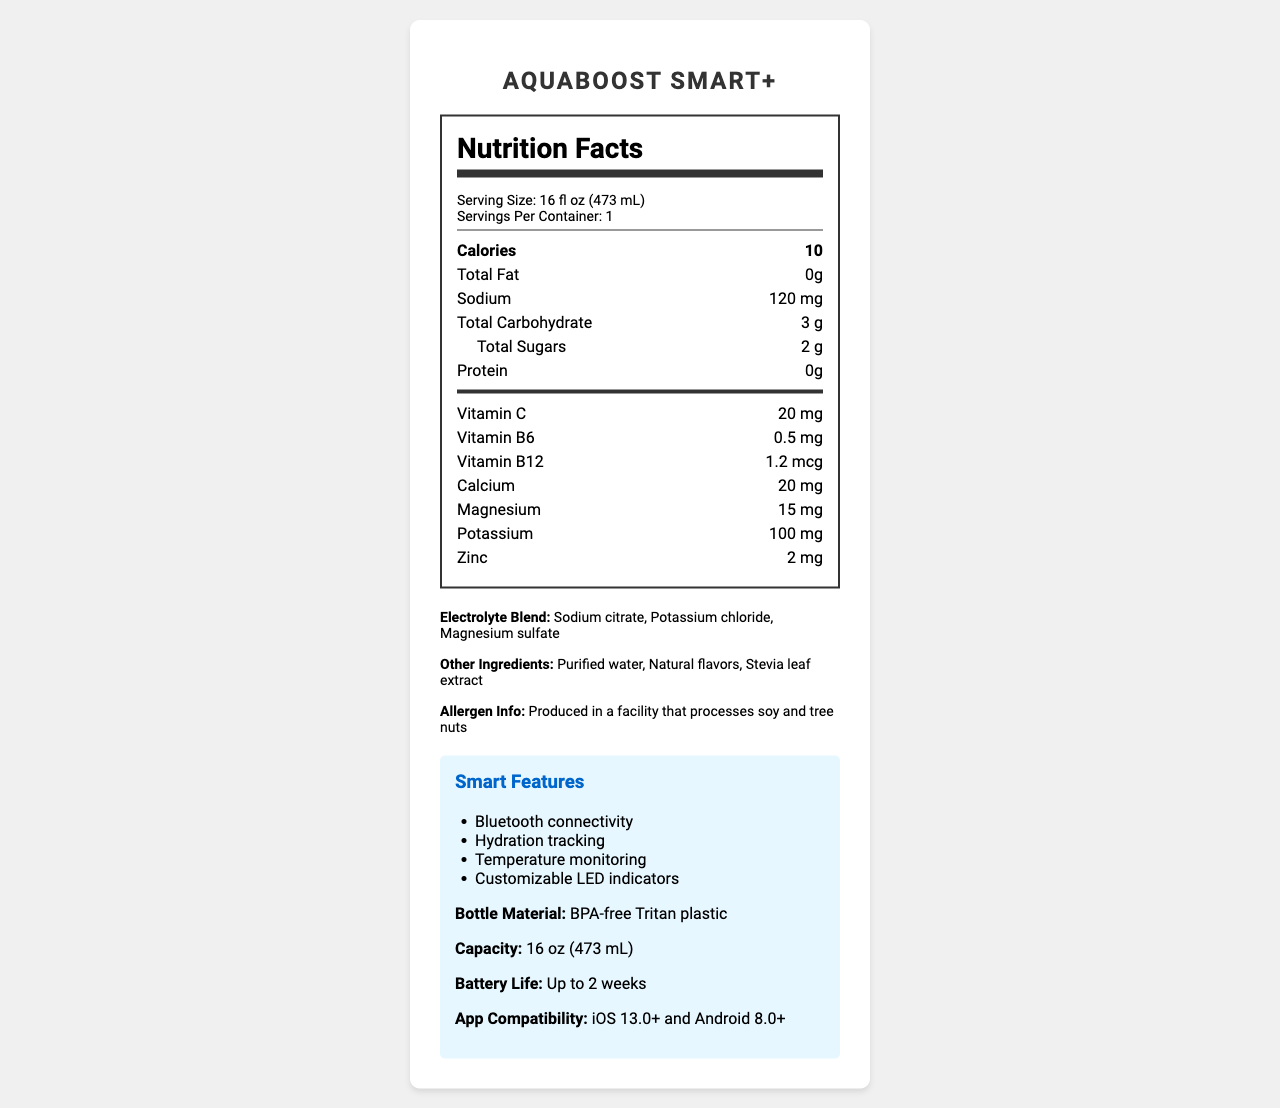what is the serving size? The serving size is specified near the top of the nutrition facts section.
Answer: 16 fl oz (473 mL) how many calories are in one serving? The number of calories per serving is listed prominently in the nutrition facts.
Answer: 10 how much sodium does the AquaBoost Smart+ contain per serving? The amount of sodium is listed in the nutrition facts under the nutrient section.
Answer: 120 mg what are the smart features of the AquaBoost Smart+? These features are listed in the smart features section of the document.
Answer: Bluetooth connectivity, Hydration tracking, Temperature monitoring, Customizable LED indicators what is the bottle material? The bottle material is mentioned in the smart features section.
Answer: BPA-free Tritan plastic how much vitamin C is in a serving of AquaBoost Smart+? The amount of vitamin C is specified in the vitamin section of the nutrition facts.
Answer: 20 mg what are the options for color? A. Slate Grey, Arctic White, Midnight Black B. Red, Blue, Green C. Black, White, Blue The color options are listed in the product description.
Answer: A. Slate Grey, Arctic White, Midnight Black how much total carbohydrate does the AquaBoost Smart+ contain? A. 10 g B. 3 g C. 5 g D. 0 g The total carbohydrate content is listed under the nutrient section of the nutrition facts.
Answer: B. 3 g does the AquaBoost Smart+ contain protein? The protein content is listed as 0 grams in the nutrition facts.
Answer: No can the AquaBoost Smart+ hydrate for more than one serving per container? The servings per container are listed as 1.
Answer: No summarize the AquaBoost Smart+ document. The document provides detailed information about the AquaBoost Smart+, including its nutritional content, smart features, material, capacity, battery life, and compatibility, targeting tech-savvy professionals seeking optimal hydration and sleek design.
Answer: AquaBoost Smart+ is a 16 fl oz (473 mL) smart water bottle that includes added electrolytes and vitamins, with a minimalist design and features like Bluetooth connectivity, hydration tracking, and temperature monitoring. It is made of BPA-free Tritan plastic, has a battery life of up to 2 weeks, and is compatible with iOS 13.0+ and Android 8.0+. The nutrition facts highlight 10 calories, 120 mg sodium, 3 g total carbohydrates, and various vitamins and minerals. what is the main idea of the AquaBoost Smart+ document? The main idea focuses on the product's unique combination of hydration enhancement and smart technology, emphasizing its suitability for tech-savvy users.
Answer: The AquaBoost Smart+ is a smart water bottle with added electrolytes and vitamins, designed for tech-savvy individuals, offering features like hydration tracking and a minimalist design. how many grams of total sugars does the AquaBoost Smart+ have? The total sugars are listed under the total carbohydrate section in the nutrition facts.
Answer: 2 g where is it produced? The production location is not listed in the document.
Answer: Cannot be determined does the AquaBoost Smart+ bottle track hydration? Hydration tracking is listed as one of the smart features.
Answer: Yes what are the allergy warnings for the AquaBoost Smart+? The allergen information is listed at the bottom of the ingredients section.
Answer: Produced in a facility that processes soy and tree nuts how long does the battery last on the AquaBoost Smart+? The battery life is mentioned in the smart features section.
Answer: Up to 2 weeks 